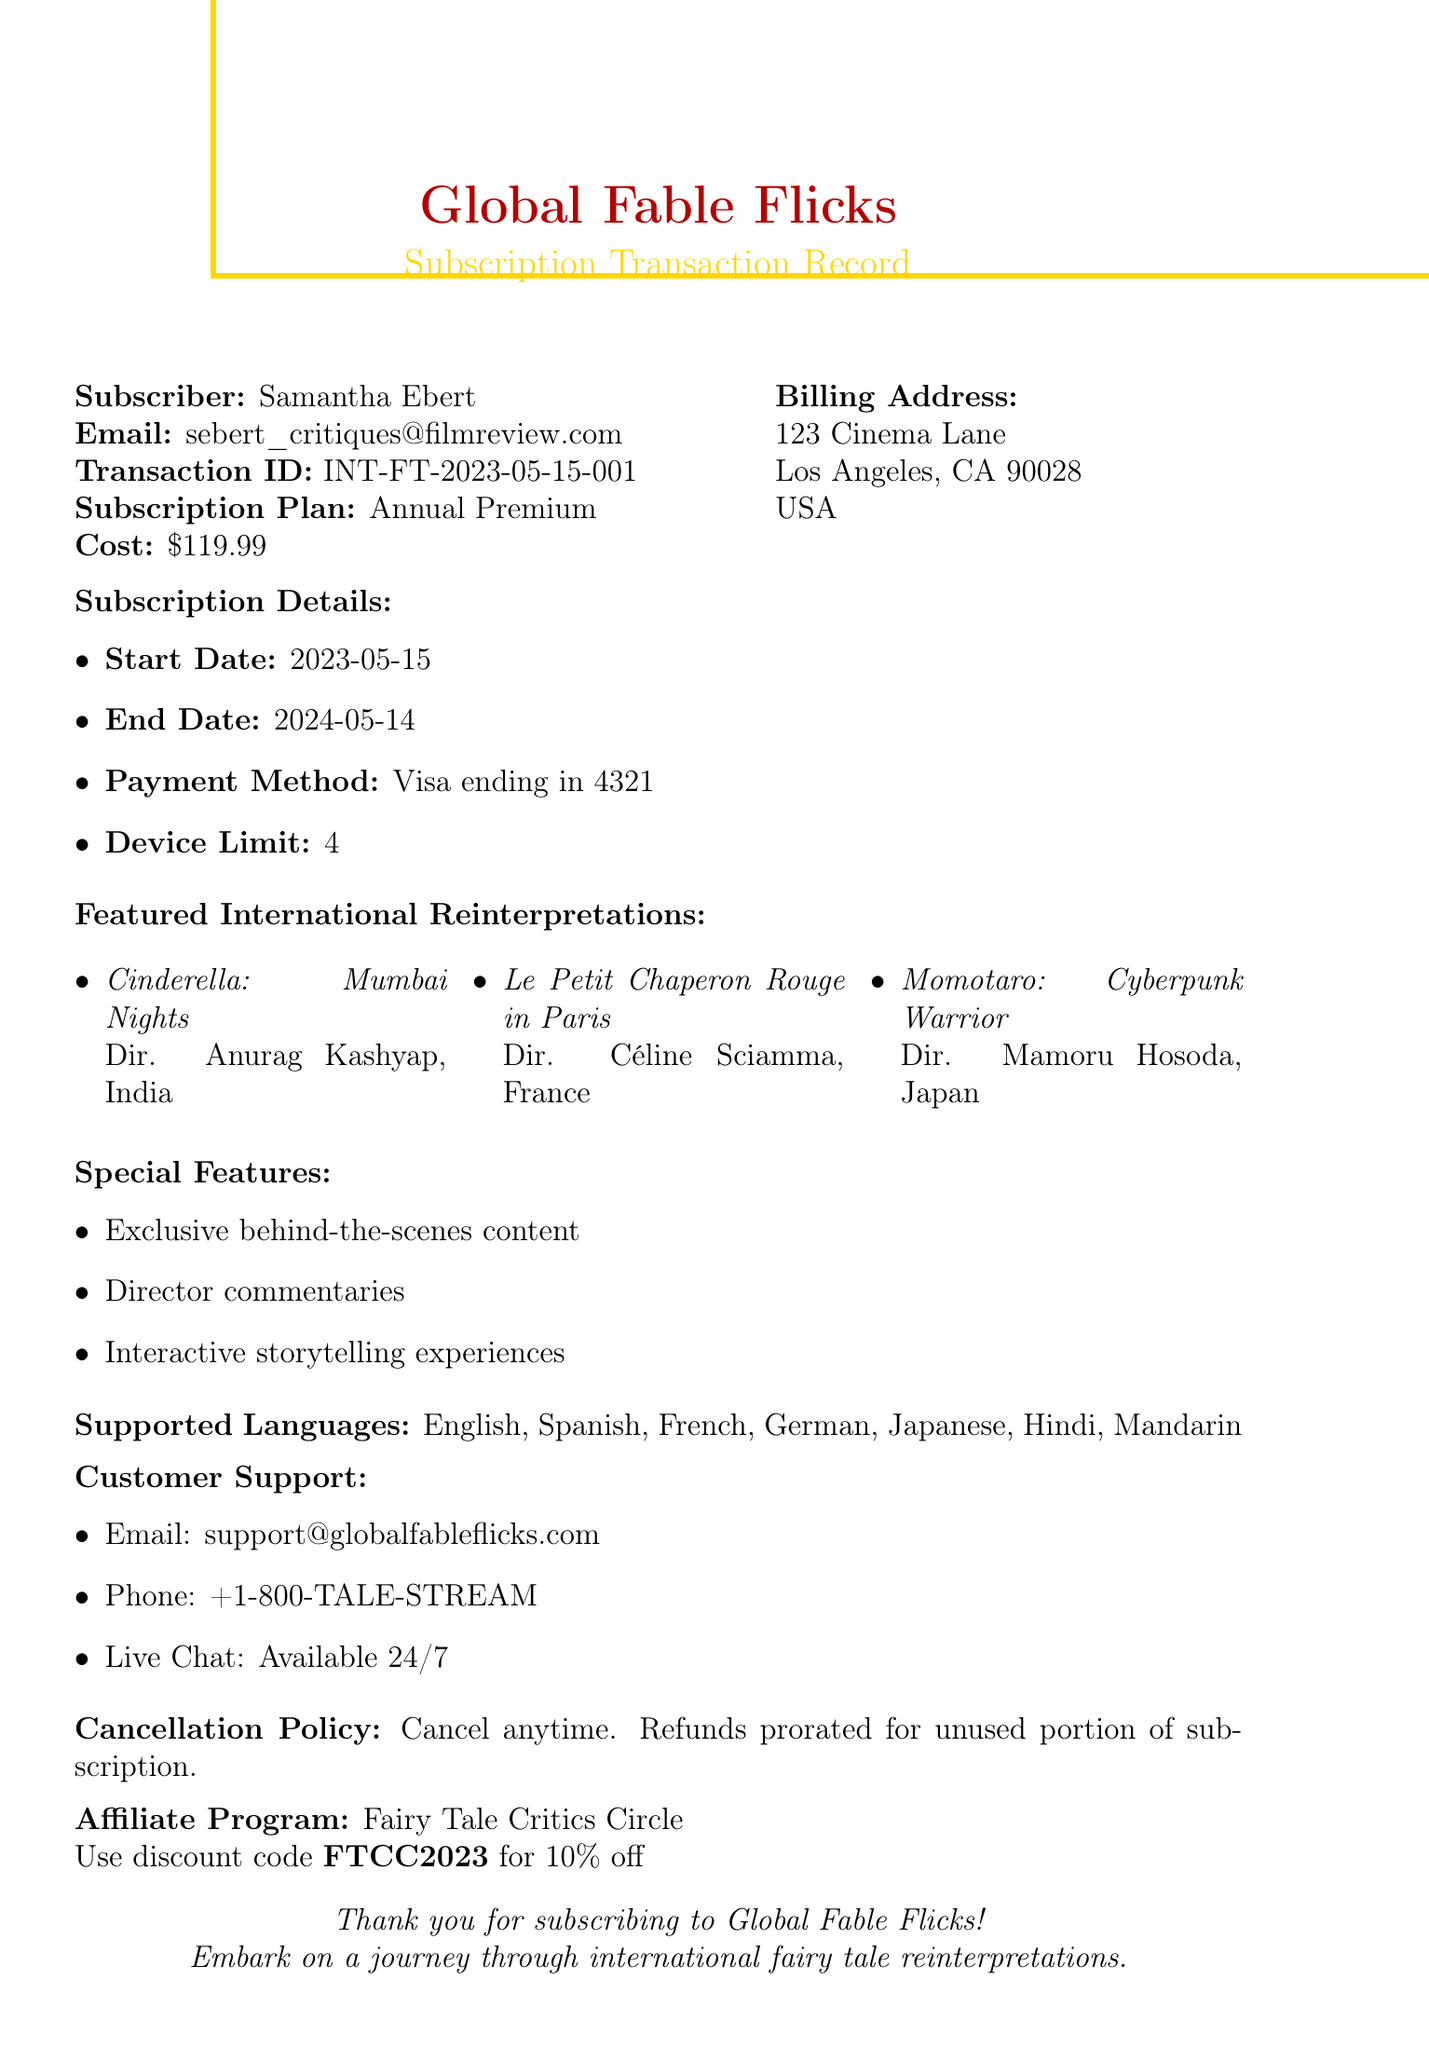What is the subscriber's name? The subscriber's name is listed at the beginning of the document under Subscriber information.
Answer: Samantha Ebert What is the subscription cost? The subscription cost is provided in the Subscription Details section of the document.
Answer: $119.99 When does the subscription end? The end date of the subscription is specified in the Subscription Details section.
Answer: 2024-05-14 How many device limits are allowed for this subscription? The document specifies the maximum number of devices allowed under Subscription Details.
Answer: 4 Who directed "Cinderella: Mumbai Nights"? The director's name is mentioned alongside the featured content in the document.
Answer: Anurag Kashyap What cancellation policy is mentioned? The cancellation policy is detailed in the document, outlining the terms of cancellation.
Answer: Cancel anytime. Refunds prorated for unused portion of subscription What special feature is available for subscribers? A specific item from the Special Features list in the document can be referenced.
Answer: Exclusive behind-the-scenes content What discount can be obtained through the affiliate program? The discount amount is stated in the Affiliate Program section of the document.
Answer: 10% How can customers reach support via phone? The customer support contact method is outlined in the Customer Support section.
Answer: +1-800-TALE-STREAM 